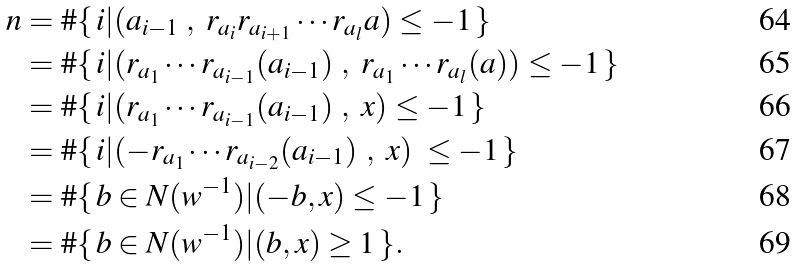<formula> <loc_0><loc_0><loc_500><loc_500>n & = \# \{ \, i | ( a _ { i - 1 } \ , \ r _ { a _ { i } } r _ { a _ { i + 1 } } \cdots r _ { a _ { l } } a ) \leq - 1 \, \} \\ & = \# \{ \, i | ( r _ { a _ { 1 } } \cdots r _ { a _ { i - 1 } } ( a _ { i - 1 } ) \ , \ r _ { a _ { 1 } } \cdots r _ { a _ { l } } ( a ) ) \leq - 1 \, \} \\ & = \# \{ \, i | ( r _ { a _ { 1 } } \cdots r _ { a _ { i - 1 } } ( a _ { i - 1 } ) \ , \ x ) \leq - 1 \, \} \\ & = \# \{ \, i | ( - r _ { a _ { 1 } } \cdots r _ { a _ { i - 2 } } ( a _ { i - 1 } ) \ , \ x ) \ \leq - 1 \, \} \\ & = \# \{ \, b \in N ( w ^ { - 1 } ) | ( - b , x ) \leq - 1 \, \} \\ & = \# \{ \, b \in N ( w ^ { - 1 } ) | ( b , x ) \geq 1 \, \} .</formula> 